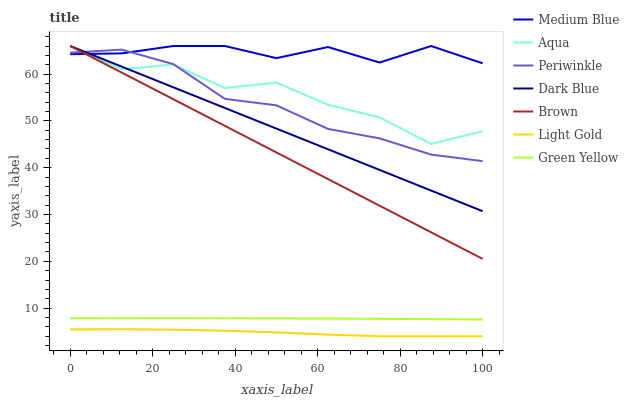Does Light Gold have the minimum area under the curve?
Answer yes or no. Yes. Does Medium Blue have the maximum area under the curve?
Answer yes or no. Yes. Does Aqua have the minimum area under the curve?
Answer yes or no. No. Does Aqua have the maximum area under the curve?
Answer yes or no. No. Is Dark Blue the smoothest?
Answer yes or no. Yes. Is Aqua the roughest?
Answer yes or no. Yes. Is Medium Blue the smoothest?
Answer yes or no. No. Is Medium Blue the roughest?
Answer yes or no. No. Does Aqua have the lowest value?
Answer yes or no. No. Does Periwinkle have the highest value?
Answer yes or no. No. Is Green Yellow less than Aqua?
Answer yes or no. Yes. Is Dark Blue greater than Green Yellow?
Answer yes or no. Yes. Does Green Yellow intersect Aqua?
Answer yes or no. No. 